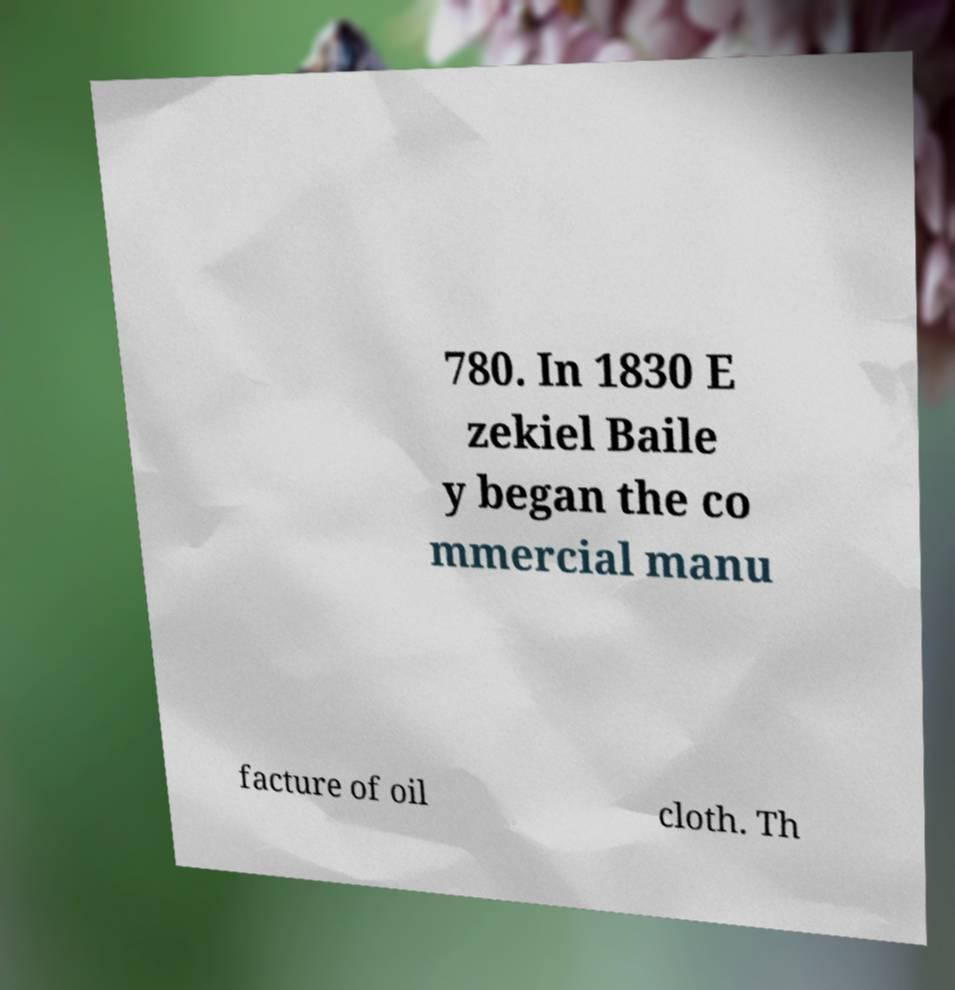Please read and relay the text visible in this image. What does it say? 780. In 1830 E zekiel Baile y began the co mmercial manu facture of oil cloth. Th 